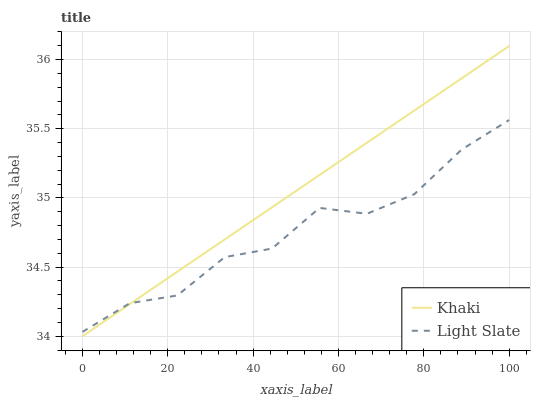Does Khaki have the minimum area under the curve?
Answer yes or no. No. Is Khaki the roughest?
Answer yes or no. No. 